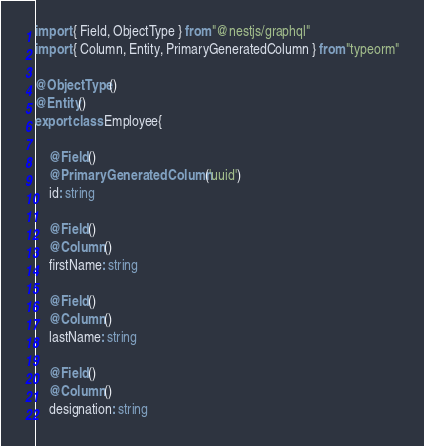<code> <loc_0><loc_0><loc_500><loc_500><_TypeScript_>import { Field, ObjectType } from "@nestjs/graphql"
import { Column, Entity, PrimaryGeneratedColumn } from "typeorm"

@ObjectType()
@Entity()
export class Employee{

    @Field()
    @PrimaryGeneratedColumn('uuid')
    id: string

    @Field()
    @Column()
    firstName: string

    @Field()
    @Column()
    lastName: string

    @Field()
    @Column()
    designation: string
</code> 